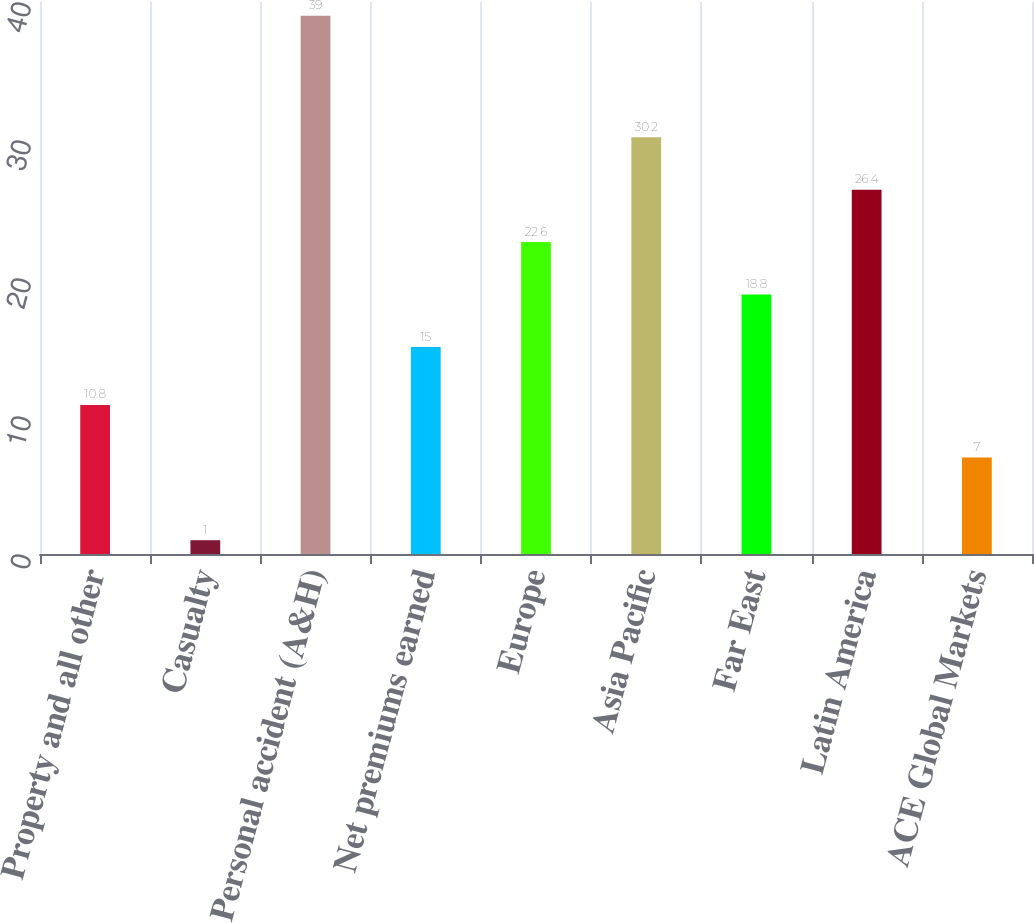Convert chart. <chart><loc_0><loc_0><loc_500><loc_500><bar_chart><fcel>Property and all other<fcel>Casualty<fcel>Personal accident (A&H)<fcel>Net premiums earned<fcel>Europe<fcel>Asia Pacific<fcel>Far East<fcel>Latin America<fcel>ACE Global Markets<nl><fcel>10.8<fcel>1<fcel>39<fcel>15<fcel>22.6<fcel>30.2<fcel>18.8<fcel>26.4<fcel>7<nl></chart> 